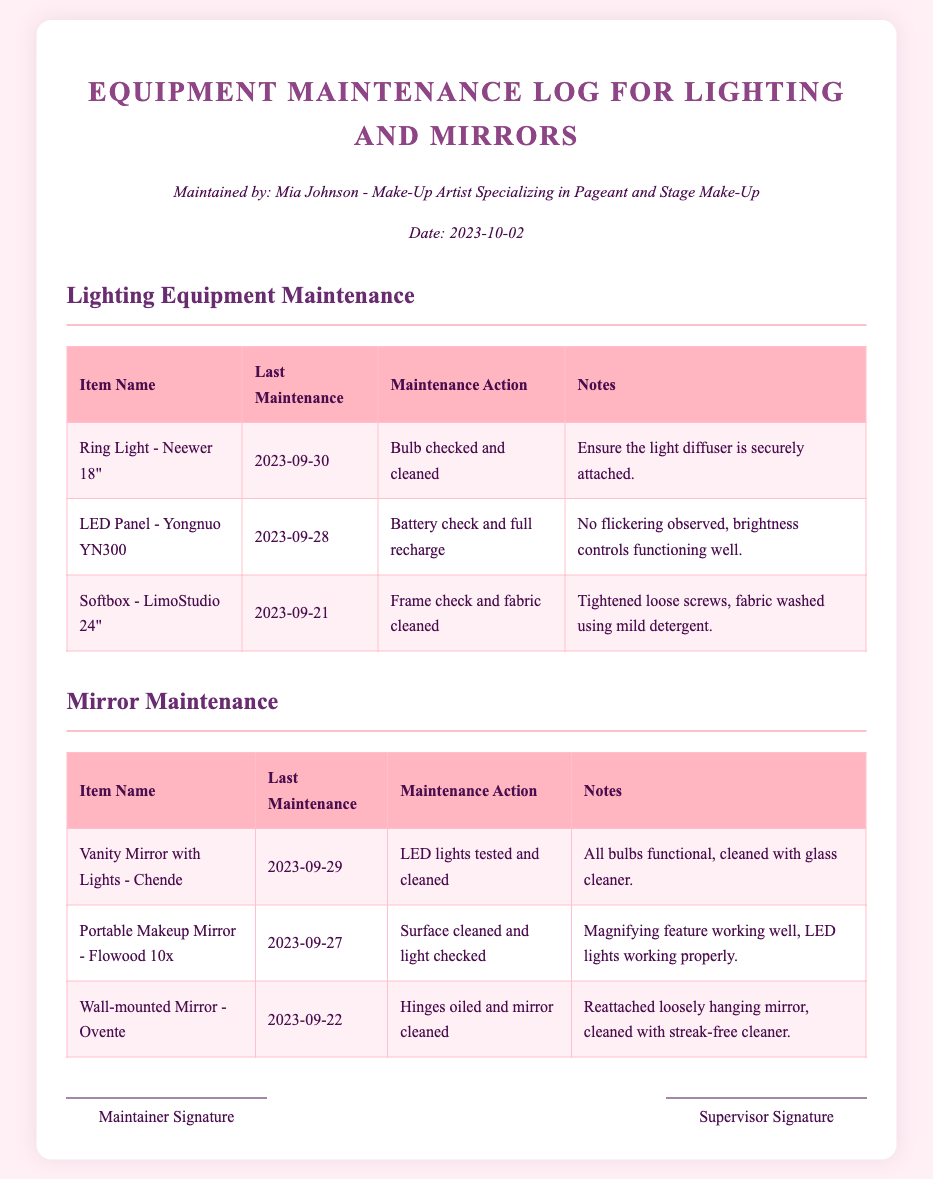what is the name of the maintainer? The maintainer responsible for this equipment maintenance log is Mia Johnson.
Answer: Mia Johnson when was the last maintenance for the Ring Light? The last maintenance date for the Ring Light is September 30, 2023.
Answer: 2023-09-30 what maintenance action was taken for the Portable Makeup Mirror? The maintenance action for the Portable Makeup Mirror was surface cleaned and light checked.
Answer: Surface cleaned and light checked how many items are listed under Lighting Equipment Maintenance? There are three items listed under the Lighting Equipment Maintenance section.
Answer: 3 which mirror had its LED lights tested? The Vanity Mirror with Lights had its LED lights tested.
Answer: Vanity Mirror with Lights - Chende what notes were made for the Softbox? The notes for the Softbox mentioned that loose screws were tightened and the fabric was washed using mild detergent.
Answer: Tightened loose screws, fabric washed using mild detergent when was the last maintenance for the Wall-mounted Mirror? The last maintenance for the Wall-mounted Mirror was on September 22, 2023.
Answer: 2023-09-22 what action was performed on the hinges of the Wall-mounted Mirror? The hinges of the Wall-mounted Mirror were oiled.
Answer: Hinges oiled how many different types of mirrors are listed in the log? There are three different types of mirrors listed in the log.
Answer: 3 